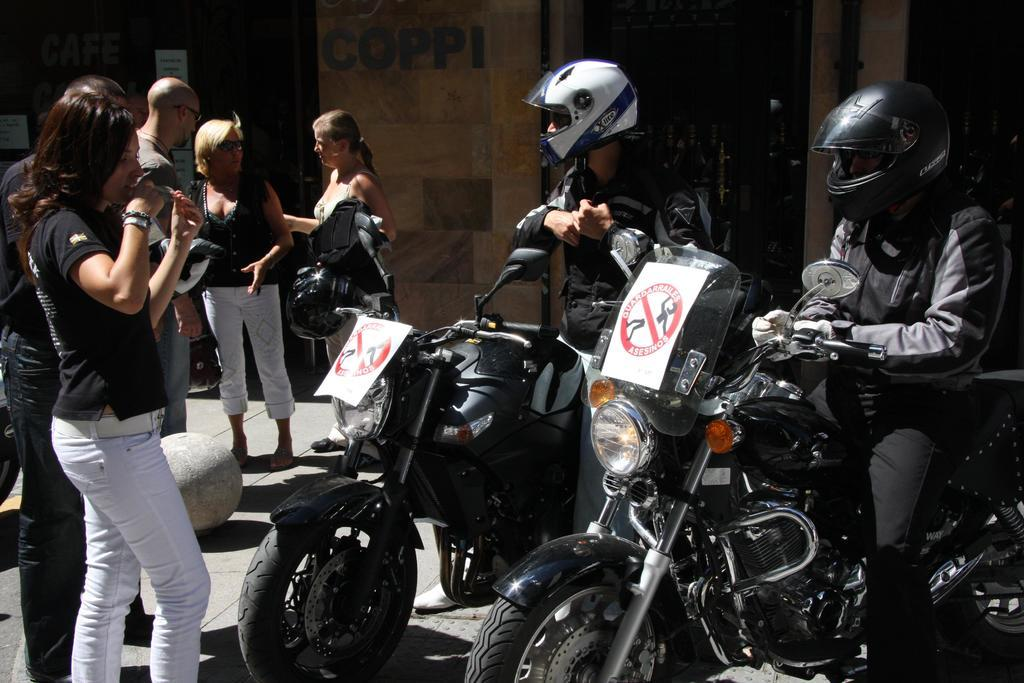How many people are in the image? There are two people in the image. What are the people wearing that is similar? Both people are wearing black jackets and helmets. What are the people doing in the image? The two people are sitting on a motorbike. How does the sugar content in the image compare to that of a different image? There is no sugar present in the image, so it cannot be compared to another image's sugar content. 